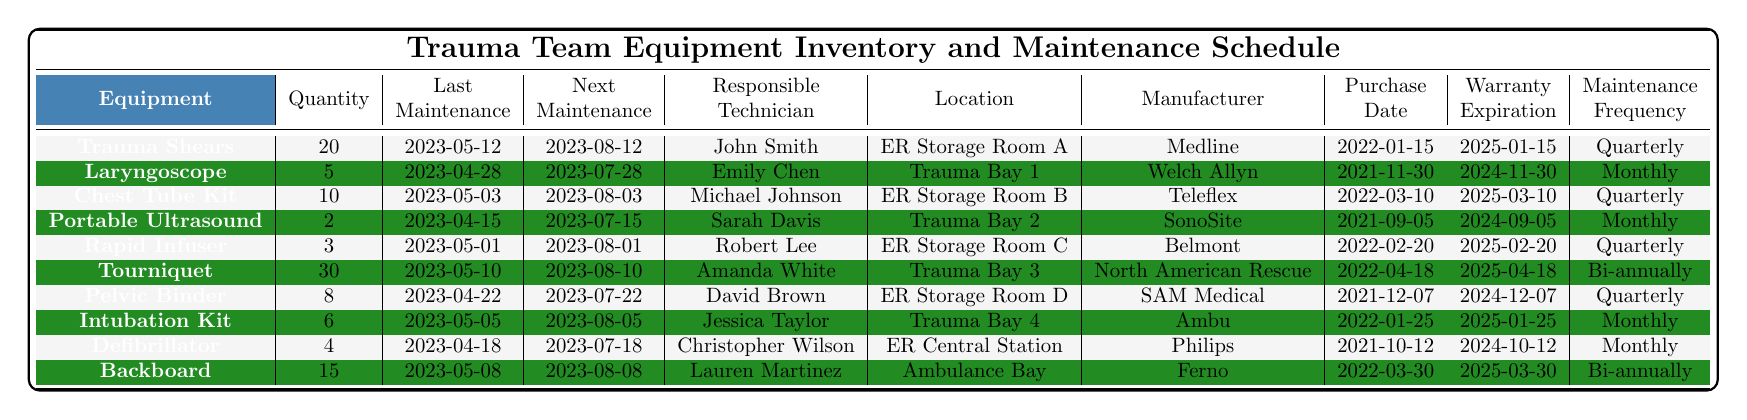What is the quantity of Trauma Shears available? The table shows that Trauma Shears have a quantity listed in the second column next to their name, which is 20.
Answer: 20 When is the next maintenance date for the Laryngoscope? The next maintenance date for the Laryngoscope is found in the fourth column next to its name, which indicates 2023-07-28.
Answer: 2023-07-28 Who is responsible for maintaining the Chest Tube Kit? The responsible technician is listed in the fifth column next to the Chest Tube Kit, and it shows Michael Johnson.
Answer: Michael Johnson What is the maintenance frequency for the Portable Ultrasound? Checking the maintenance frequency column next to the Portable Ultrasound reveals that it is maintained Monthly.
Answer: Monthly How many pieces of equipment have a next maintenance date in August 2023? We count the entries in the next maintenance date column, and find 5 entries have dates in August, specifically for Trauma Shears, Chest Tube Kit, Rapid Infuser, Tourniquet, and Intubation Kit.
Answer: 5 What is the total quantity of all equipment? Adding all quantities from the second column (20 + 5 + 10 + 2 + 3 + 30 + 8 + 6 + 4 + 15) gives a total of 103.
Answer: 103 Is the Warranty Expiration Date for the Tourniquet after 2025? The Warranty Expiration Date for the Tourniquet is 2025-04-18. Since this date is in the year 2025, the answer is false.
Answer: No Which equipment is located in Trauma Bay 3, and when is it scheduled for its next maintenance? The equipment located in Trauma Bay 3 is the Tourniquet, and its next maintenance date is 2023-08-10.
Answer: Tourniquet, 2023-08-10 How many items were manufactured by Medline, and when do they need maintenance next? The only item manufactured by Medline, Trauma Shears, needs its next maintenance on 2023-08-12. Thus, there is 1 item needing maintenance.
Answer: 1, 2023-08-12 Which two pieces of equipment have the longest duration until their next maintenance? Looking at the next maintenance dates, the Portable Ultrasound and Tourniquet will be due for maintenance in July which is earlier than the others except for the Tourniquet which has a later date of 2023-08-10.
Answer: Portable Ultrasound, Tourniquet 